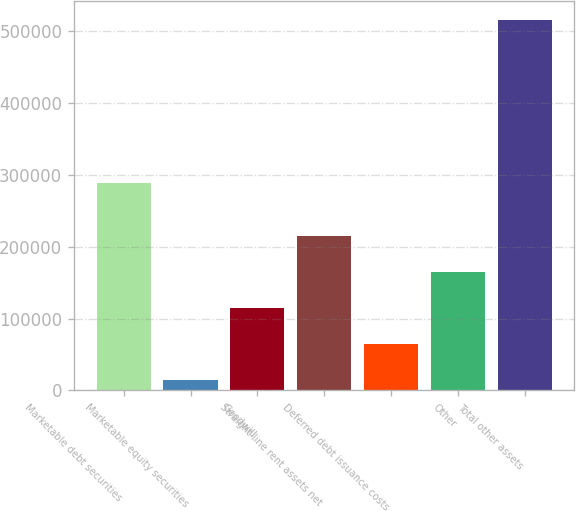Convert chart to OTSL. <chart><loc_0><loc_0><loc_500><loc_500><bar_chart><fcel>Marketable debt securities<fcel>Marketable equity securities<fcel>Goodwill<fcel>Straight-line rent assets net<fcel>Deferred debt issuance costs<fcel>Other<fcel>Total other assets<nl><fcel>289163<fcel>13933<fcel>114373<fcel>214813<fcel>64153<fcel>164593<fcel>516133<nl></chart> 